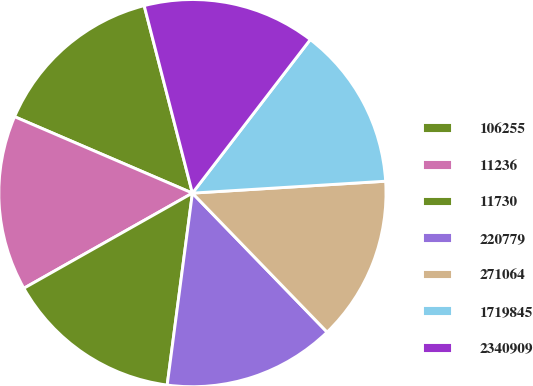<chart> <loc_0><loc_0><loc_500><loc_500><pie_chart><fcel>106255<fcel>11236<fcel>11730<fcel>220779<fcel>271064<fcel>1719845<fcel>2340909<nl><fcel>14.53%<fcel>14.64%<fcel>14.74%<fcel>14.33%<fcel>13.73%<fcel>13.6%<fcel>14.43%<nl></chart> 